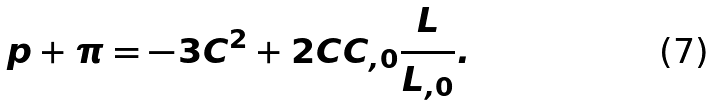Convert formula to latex. <formula><loc_0><loc_0><loc_500><loc_500>p + \pi = - 3 C ^ { 2 } + 2 C C _ { , 0 } \frac { L } { L _ { , 0 } } .</formula> 